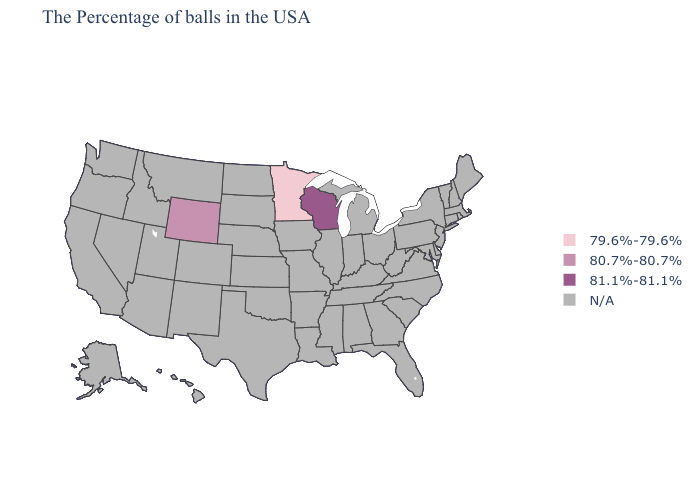Does Wyoming have the lowest value in the USA?
Keep it brief. No. Does the map have missing data?
Quick response, please. Yes. Name the states that have a value in the range N/A?
Give a very brief answer. Maine, Massachusetts, Rhode Island, New Hampshire, Vermont, Connecticut, New York, New Jersey, Delaware, Maryland, Pennsylvania, Virginia, North Carolina, South Carolina, West Virginia, Ohio, Florida, Georgia, Michigan, Kentucky, Indiana, Alabama, Tennessee, Illinois, Mississippi, Louisiana, Missouri, Arkansas, Iowa, Kansas, Nebraska, Oklahoma, Texas, South Dakota, North Dakota, Colorado, New Mexico, Utah, Montana, Arizona, Idaho, Nevada, California, Washington, Oregon, Alaska, Hawaii. Does the map have missing data?
Write a very short answer. Yes. Name the states that have a value in the range N/A?
Answer briefly. Maine, Massachusetts, Rhode Island, New Hampshire, Vermont, Connecticut, New York, New Jersey, Delaware, Maryland, Pennsylvania, Virginia, North Carolina, South Carolina, West Virginia, Ohio, Florida, Georgia, Michigan, Kentucky, Indiana, Alabama, Tennessee, Illinois, Mississippi, Louisiana, Missouri, Arkansas, Iowa, Kansas, Nebraska, Oklahoma, Texas, South Dakota, North Dakota, Colorado, New Mexico, Utah, Montana, Arizona, Idaho, Nevada, California, Washington, Oregon, Alaska, Hawaii. Does Minnesota have the highest value in the USA?
Keep it brief. No. What is the lowest value in the USA?
Concise answer only. 79.6%-79.6%. Name the states that have a value in the range 81.1%-81.1%?
Concise answer only. Wisconsin. What is the value of Massachusetts?
Keep it brief. N/A. Which states have the highest value in the USA?
Concise answer only. Wisconsin. Which states hav the highest value in the West?
Be succinct. Wyoming. 